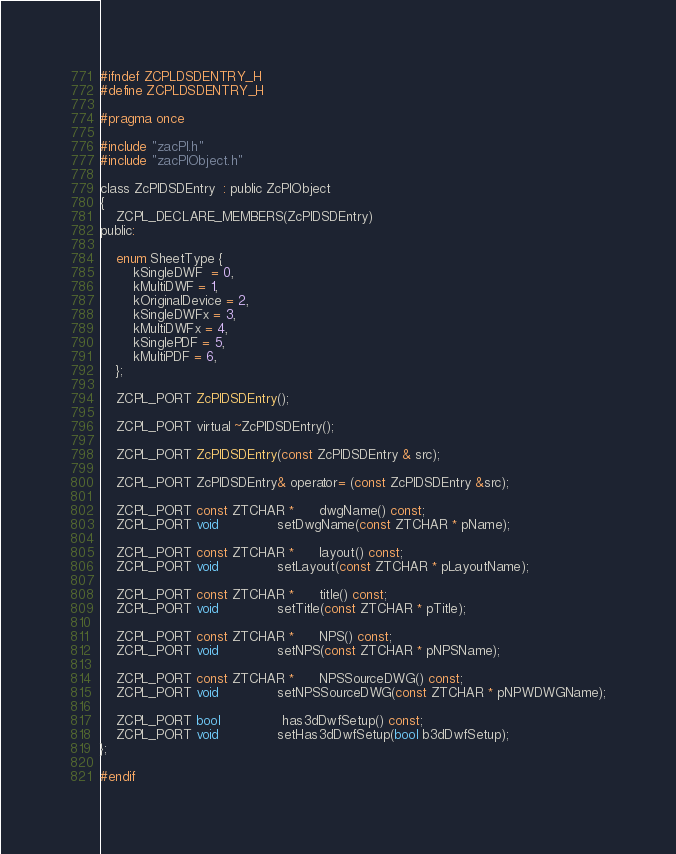<code> <loc_0><loc_0><loc_500><loc_500><_C_>

#ifndef ZCPLDSDENTRY_H
#define ZCPLDSDENTRY_H

#pragma once

#include "zacPl.h"
#include "zacPlObject.h"

class ZcPlDSDEntry  : public ZcPlObject
{
    ZCPL_DECLARE_MEMBERS(ZcPlDSDEntry)
public:

    enum SheetType {
        kSingleDWF  = 0,
        kMultiDWF = 1,
        kOriginalDevice = 2,
		kSingleDWFx = 3,
		kMultiDWFx = 4,
		kSinglePDF = 5,
		kMultiPDF = 6,
    };

    ZCPL_PORT ZcPlDSDEntry();

    ZCPL_PORT virtual ~ZcPlDSDEntry();

    ZCPL_PORT ZcPlDSDEntry(const ZcPlDSDEntry & src);

    ZCPL_PORT ZcPlDSDEntry& operator= (const ZcPlDSDEntry &src);

    ZCPL_PORT const ZTCHAR *      dwgName() const;
    ZCPL_PORT void              setDwgName(const ZTCHAR * pName);

    ZCPL_PORT const ZTCHAR *      layout() const;
    ZCPL_PORT void              setLayout(const ZTCHAR * pLayoutName);
    
    ZCPL_PORT const ZTCHAR *      title() const;
    ZCPL_PORT void              setTitle(const ZTCHAR * pTitle);
    
    ZCPL_PORT const ZTCHAR *      NPS() const;
    ZCPL_PORT void              setNPS(const ZTCHAR * pNPSName);
    
    ZCPL_PORT const ZTCHAR *      NPSSourceDWG() const;
    ZCPL_PORT void              setNPSSourceDWG(const ZTCHAR * pNPWDWGName);

    ZCPL_PORT bool               has3dDwfSetup() const;
    ZCPL_PORT void              setHas3dDwfSetup(bool b3dDwfSetup);
};

#endif 
</code> 